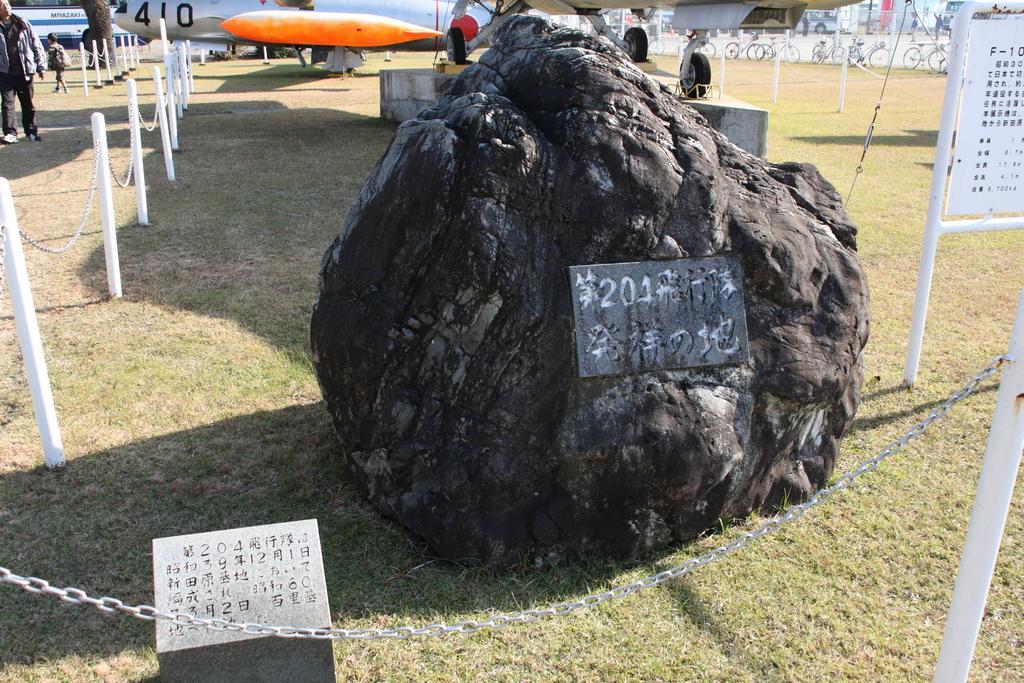How would you summarize this image in a sentence or two? In the center of the image there is a rock. On the right there is a board. At the bottom we can see a fence. In the background there are people, aeroplanes and bicycles. 